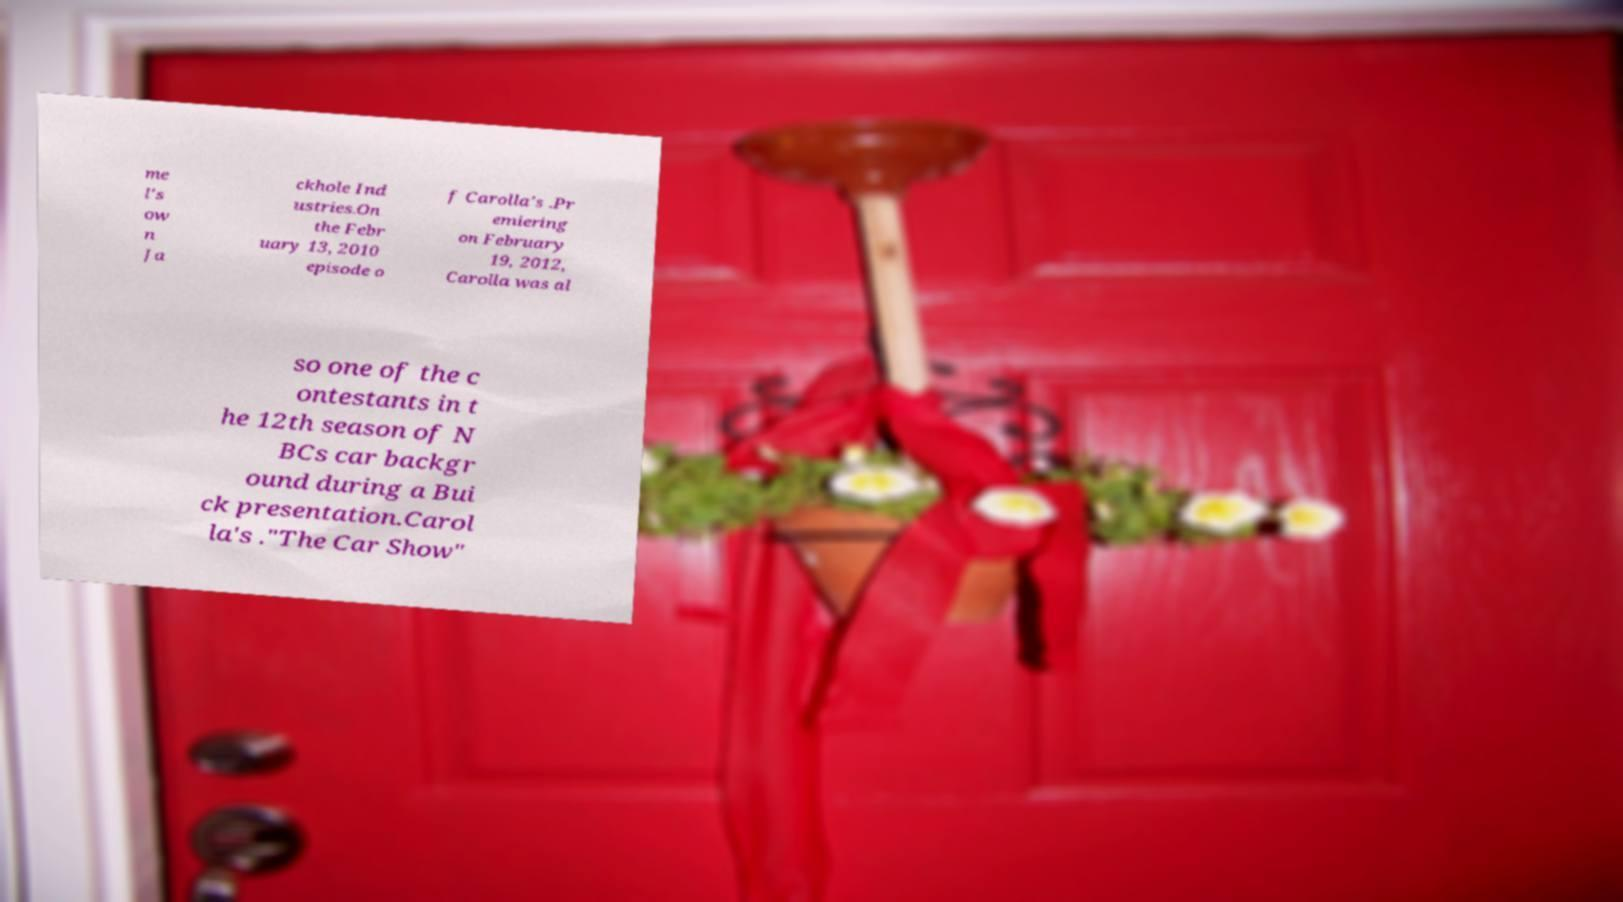For documentation purposes, I need the text within this image transcribed. Could you provide that? me l's ow n Ja ckhole Ind ustries.On the Febr uary 13, 2010 episode o f Carolla's .Pr emiering on February 19, 2012, Carolla was al so one of the c ontestants in t he 12th season of N BCs car backgr ound during a Bui ck presentation.Carol la's ."The Car Show" 